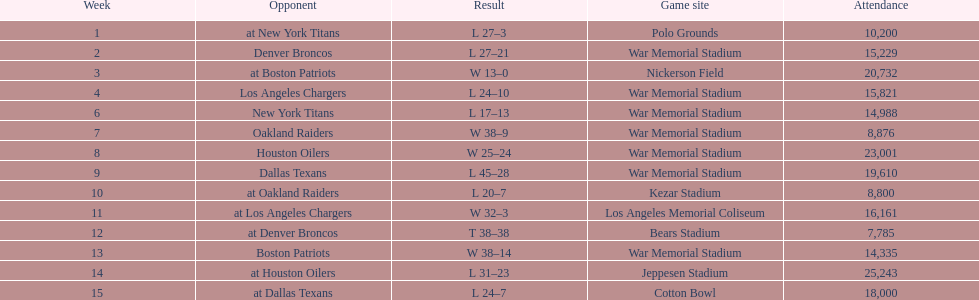What was the highest disparity in points during a single game? 29. 